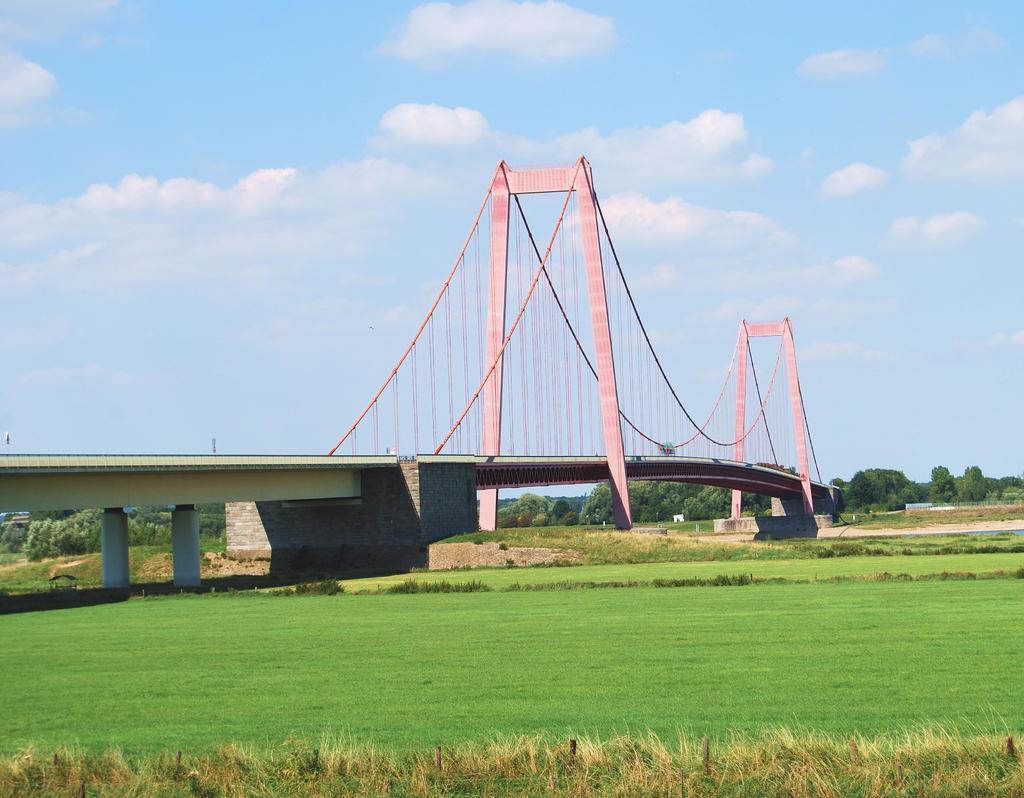How would you summarize this image in a sentence or two? In this image we can see grass on the ground. In the background we can see bridge, trees, poles and clouds in the sky. 